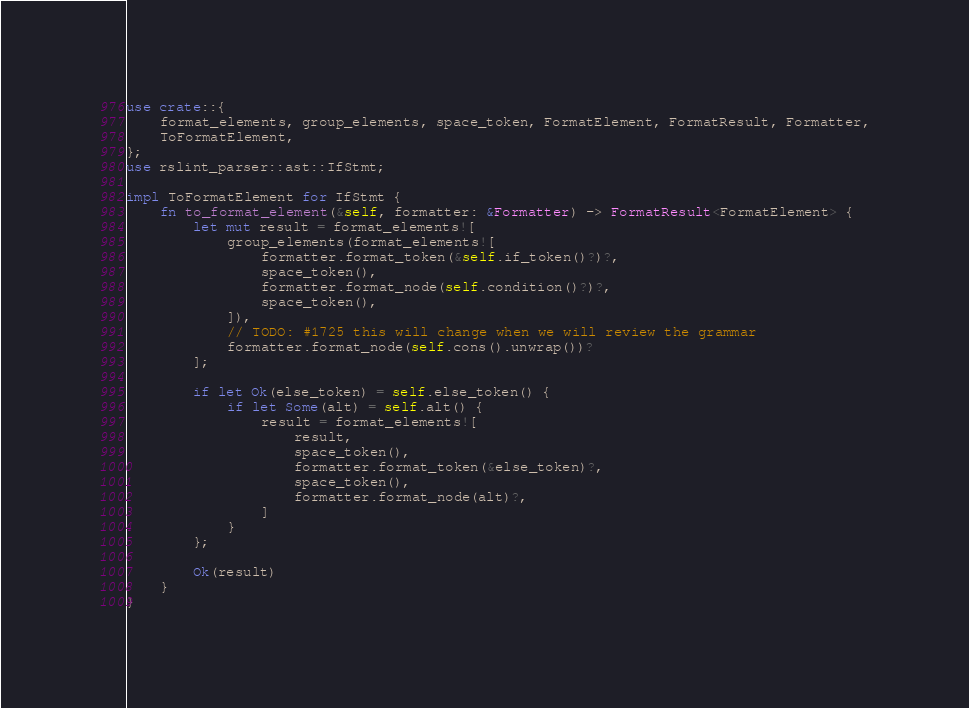<code> <loc_0><loc_0><loc_500><loc_500><_Rust_>use crate::{
	format_elements, group_elements, space_token, FormatElement, FormatResult, Formatter,
	ToFormatElement,
};
use rslint_parser::ast::IfStmt;

impl ToFormatElement for IfStmt {
	fn to_format_element(&self, formatter: &Formatter) -> FormatResult<FormatElement> {
		let mut result = format_elements![
			group_elements(format_elements![
				formatter.format_token(&self.if_token()?)?,
				space_token(),
				formatter.format_node(self.condition()?)?,
				space_token(),
			]),
			// TODO: #1725 this will change when we will review the grammar
			formatter.format_node(self.cons().unwrap())?
		];

		if let Ok(else_token) = self.else_token() {
			if let Some(alt) = self.alt() {
				result = format_elements![
					result,
					space_token(),
					formatter.format_token(&else_token)?,
					space_token(),
					formatter.format_node(alt)?,
				]
			}
		};

		Ok(result)
	}
}
</code> 